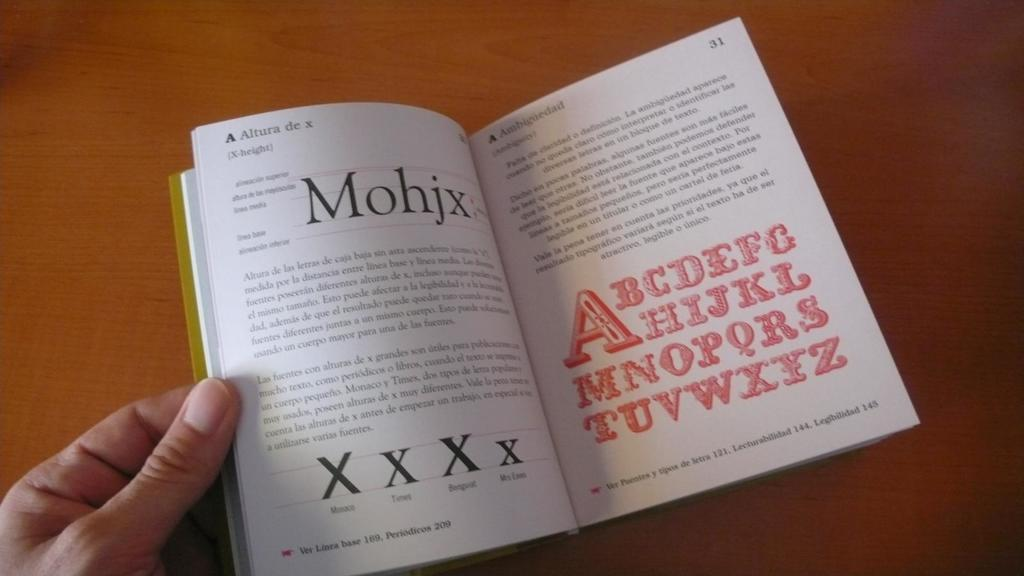<image>
Describe the image concisely. Pages 30 and 31 of a book feature the alphabet. 